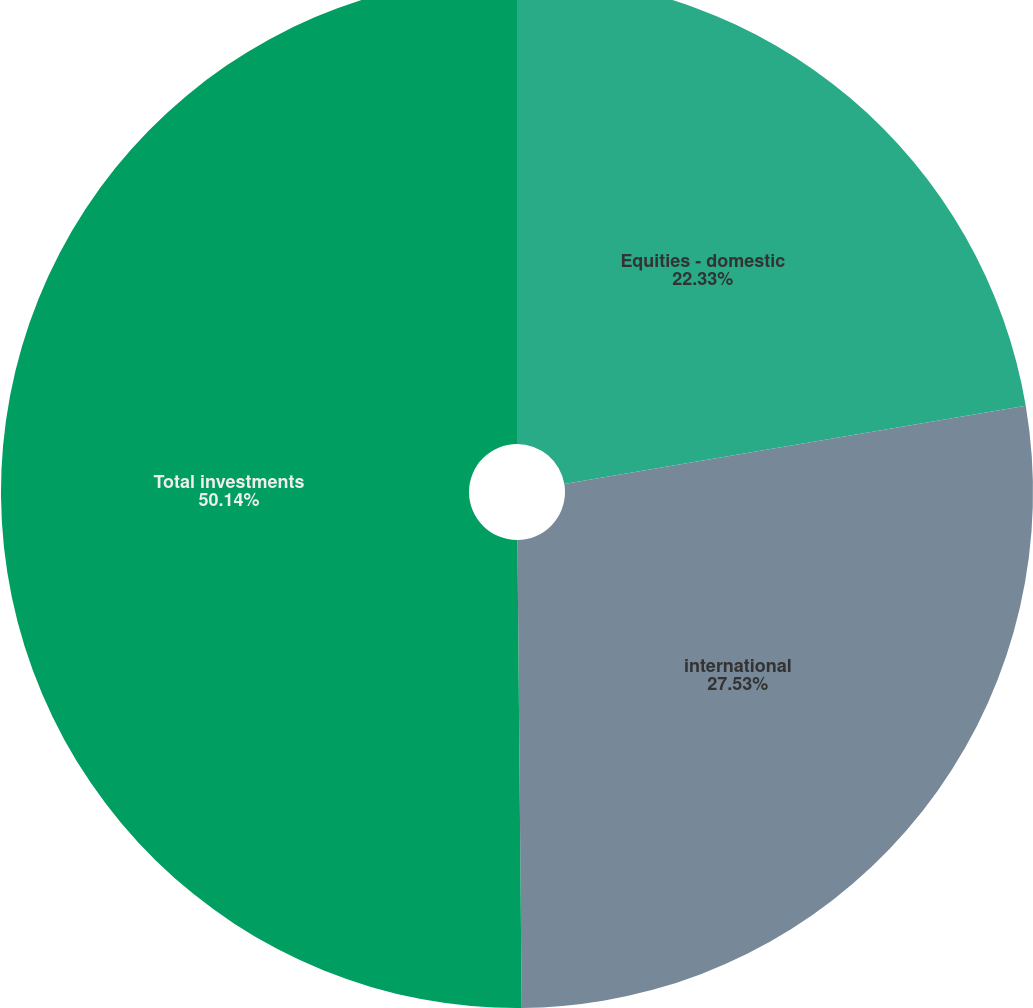Convert chart to OTSL. <chart><loc_0><loc_0><loc_500><loc_500><pie_chart><fcel>Equities - domestic<fcel>international<fcel>Total investments<nl><fcel>22.33%<fcel>27.53%<fcel>50.15%<nl></chart> 